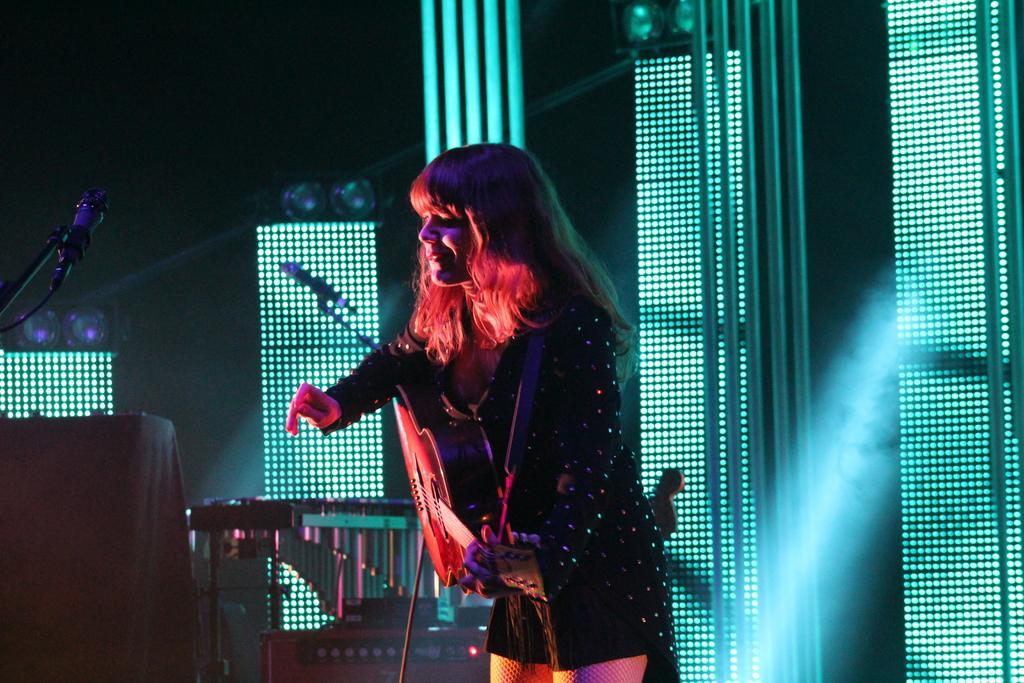In one or two sentences, can you explain what this image depicts? In this image we can see there is a girl standing and playing a guitar, in front of her there is a mic, beside her there are few musical instruments. In the background there are colorful lights and focus lights. 